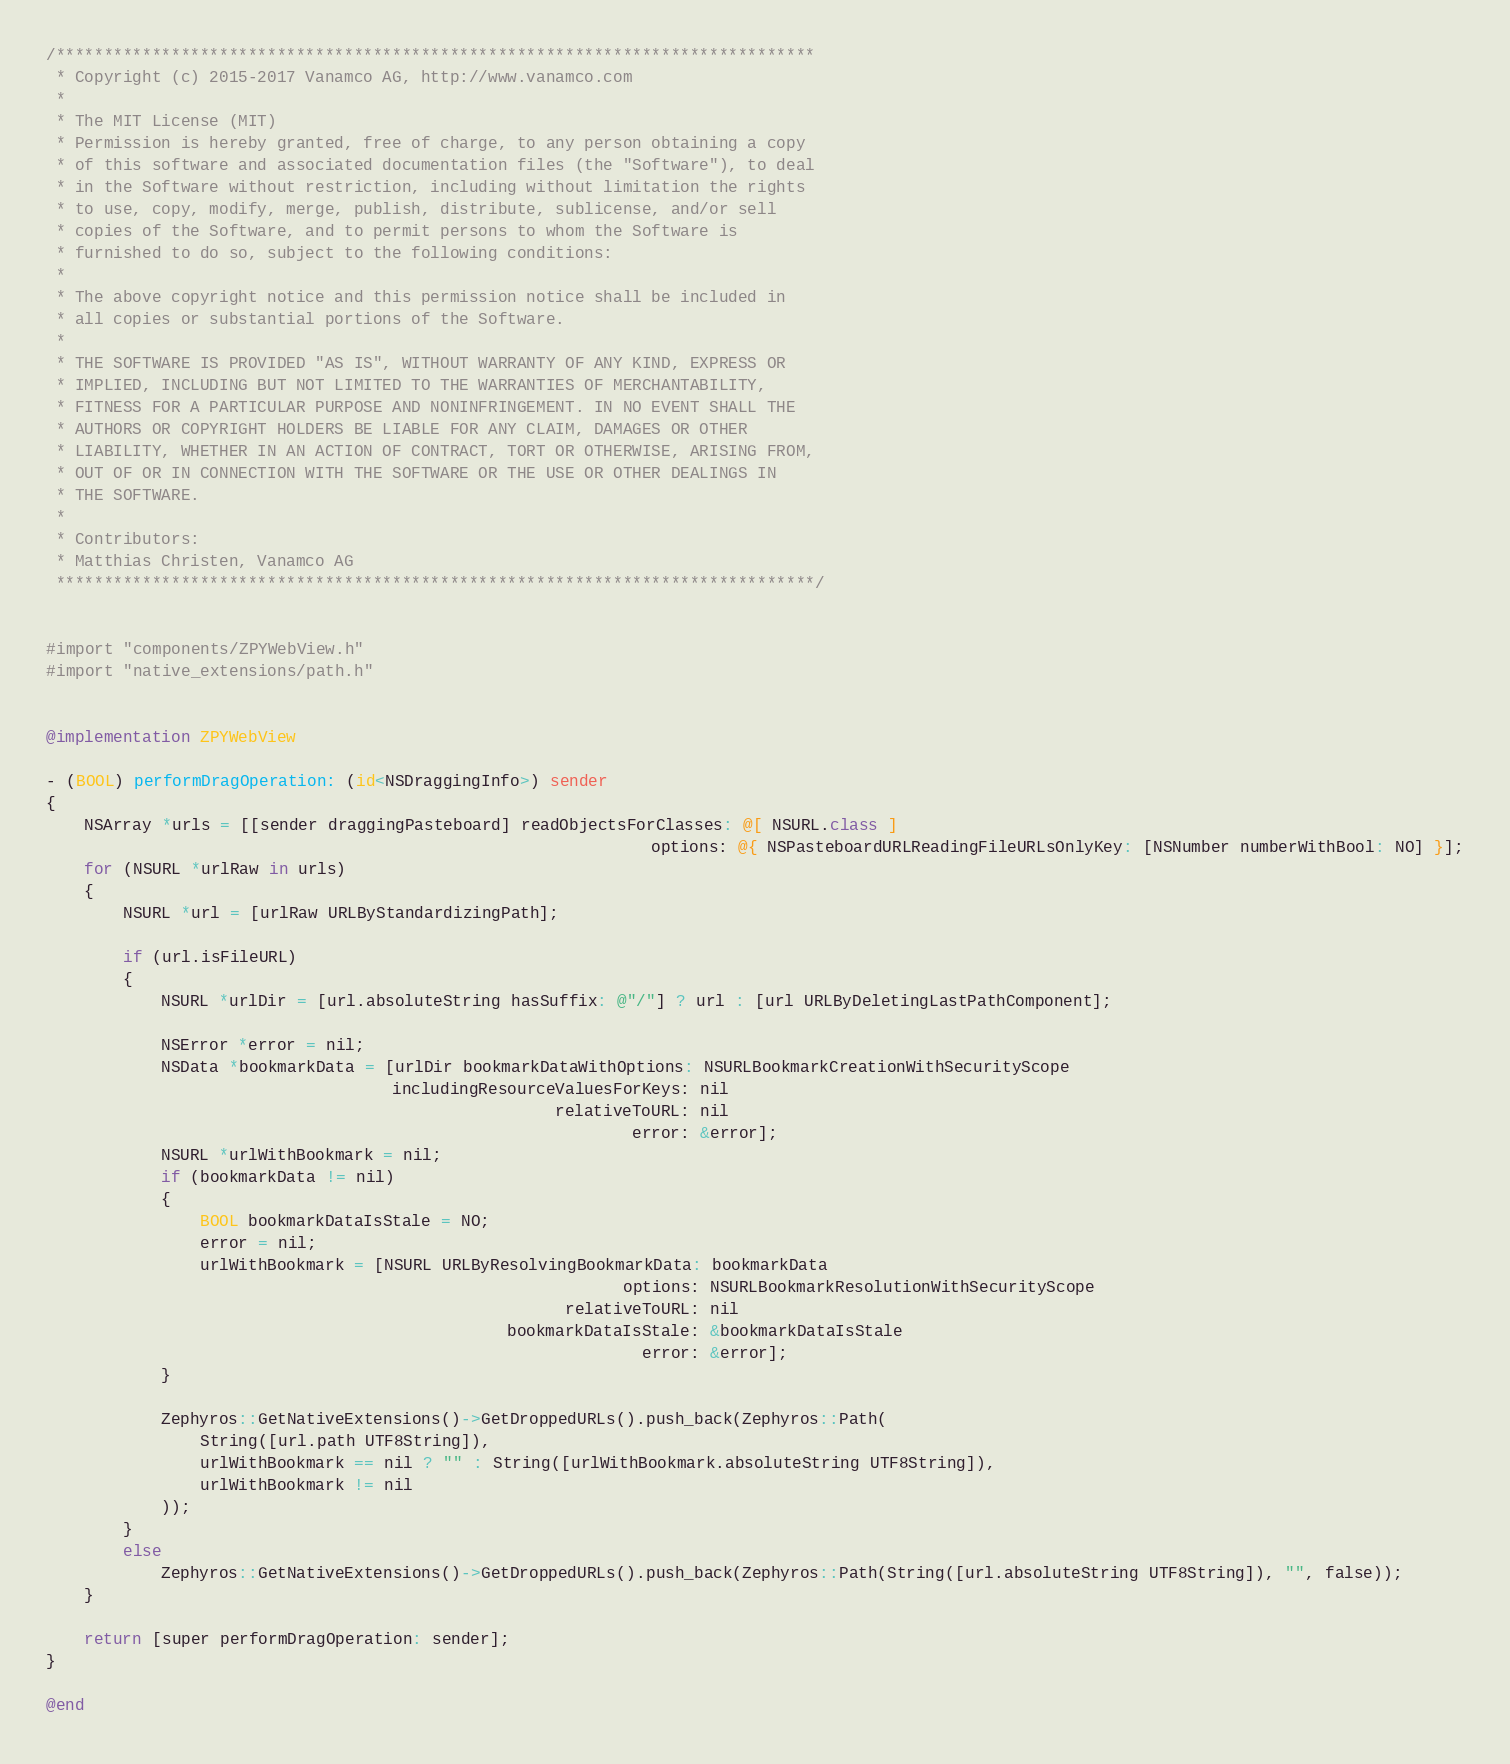<code> <loc_0><loc_0><loc_500><loc_500><_ObjectiveC_>/*******************************************************************************
 * Copyright (c) 2015-2017 Vanamco AG, http://www.vanamco.com
 *
 * The MIT License (MIT)
 * Permission is hereby granted, free of charge, to any person obtaining a copy
 * of this software and associated documentation files (the "Software"), to deal
 * in the Software without restriction, including without limitation the rights
 * to use, copy, modify, merge, publish, distribute, sublicense, and/or sell
 * copies of the Software, and to permit persons to whom the Software is
 * furnished to do so, subject to the following conditions:
 *
 * The above copyright notice and this permission notice shall be included in
 * all copies or substantial portions of the Software.
 *
 * THE SOFTWARE IS PROVIDED "AS IS", WITHOUT WARRANTY OF ANY KIND, EXPRESS OR
 * IMPLIED, INCLUDING BUT NOT LIMITED TO THE WARRANTIES OF MERCHANTABILITY,
 * FITNESS FOR A PARTICULAR PURPOSE AND NONINFRINGEMENT. IN NO EVENT SHALL THE
 * AUTHORS OR COPYRIGHT HOLDERS BE LIABLE FOR ANY CLAIM, DAMAGES OR OTHER
 * LIABILITY, WHETHER IN AN ACTION OF CONTRACT, TORT OR OTHERWISE, ARISING FROM,
 * OUT OF OR IN CONNECTION WITH THE SOFTWARE OR THE USE OR OTHER DEALINGS IN
 * THE SOFTWARE.
 *
 * Contributors:
 * Matthias Christen, Vanamco AG
 *******************************************************************************/


#import "components/ZPYWebView.h"
#import "native_extensions/path.h"


@implementation ZPYWebView

- (BOOL) performDragOperation: (id<NSDraggingInfo>) sender
{
    NSArray *urls = [[sender draggingPasteboard] readObjectsForClasses: @[ NSURL.class ]
                                                               options: @{ NSPasteboardURLReadingFileURLsOnlyKey: [NSNumber numberWithBool: NO] }];
    for (NSURL *urlRaw in urls)
    {
        NSURL *url = [urlRaw URLByStandardizingPath];
        
        if (url.isFileURL)
        {
            NSURL *urlDir = [url.absoluteString hasSuffix: @"/"] ? url : [url URLByDeletingLastPathComponent];

            NSError *error = nil;
            NSData *bookmarkData = [urlDir bookmarkDataWithOptions: NSURLBookmarkCreationWithSecurityScope
                                    includingResourceValuesForKeys: nil
                                                     relativeToURL: nil
                                                             error: &error];
            NSURL *urlWithBookmark = nil;
            if (bookmarkData != nil)
            {
                BOOL bookmarkDataIsStale = NO;
                error = nil;
                urlWithBookmark = [NSURL URLByResolvingBookmarkData: bookmarkData
                                                            options: NSURLBookmarkResolutionWithSecurityScope
                                                      relativeToURL: nil
                                                bookmarkDataIsStale: &bookmarkDataIsStale
                                                              error: &error];
            }

            Zephyros::GetNativeExtensions()->GetDroppedURLs().push_back(Zephyros::Path(
                String([url.path UTF8String]),
                urlWithBookmark == nil ? "" : String([urlWithBookmark.absoluteString UTF8String]),
                urlWithBookmark != nil
            ));
        }
        else
            Zephyros::GetNativeExtensions()->GetDroppedURLs().push_back(Zephyros::Path(String([url.absoluteString UTF8String]), "", false));
    }
    
    return [super performDragOperation: sender];
}

@end
</code> 